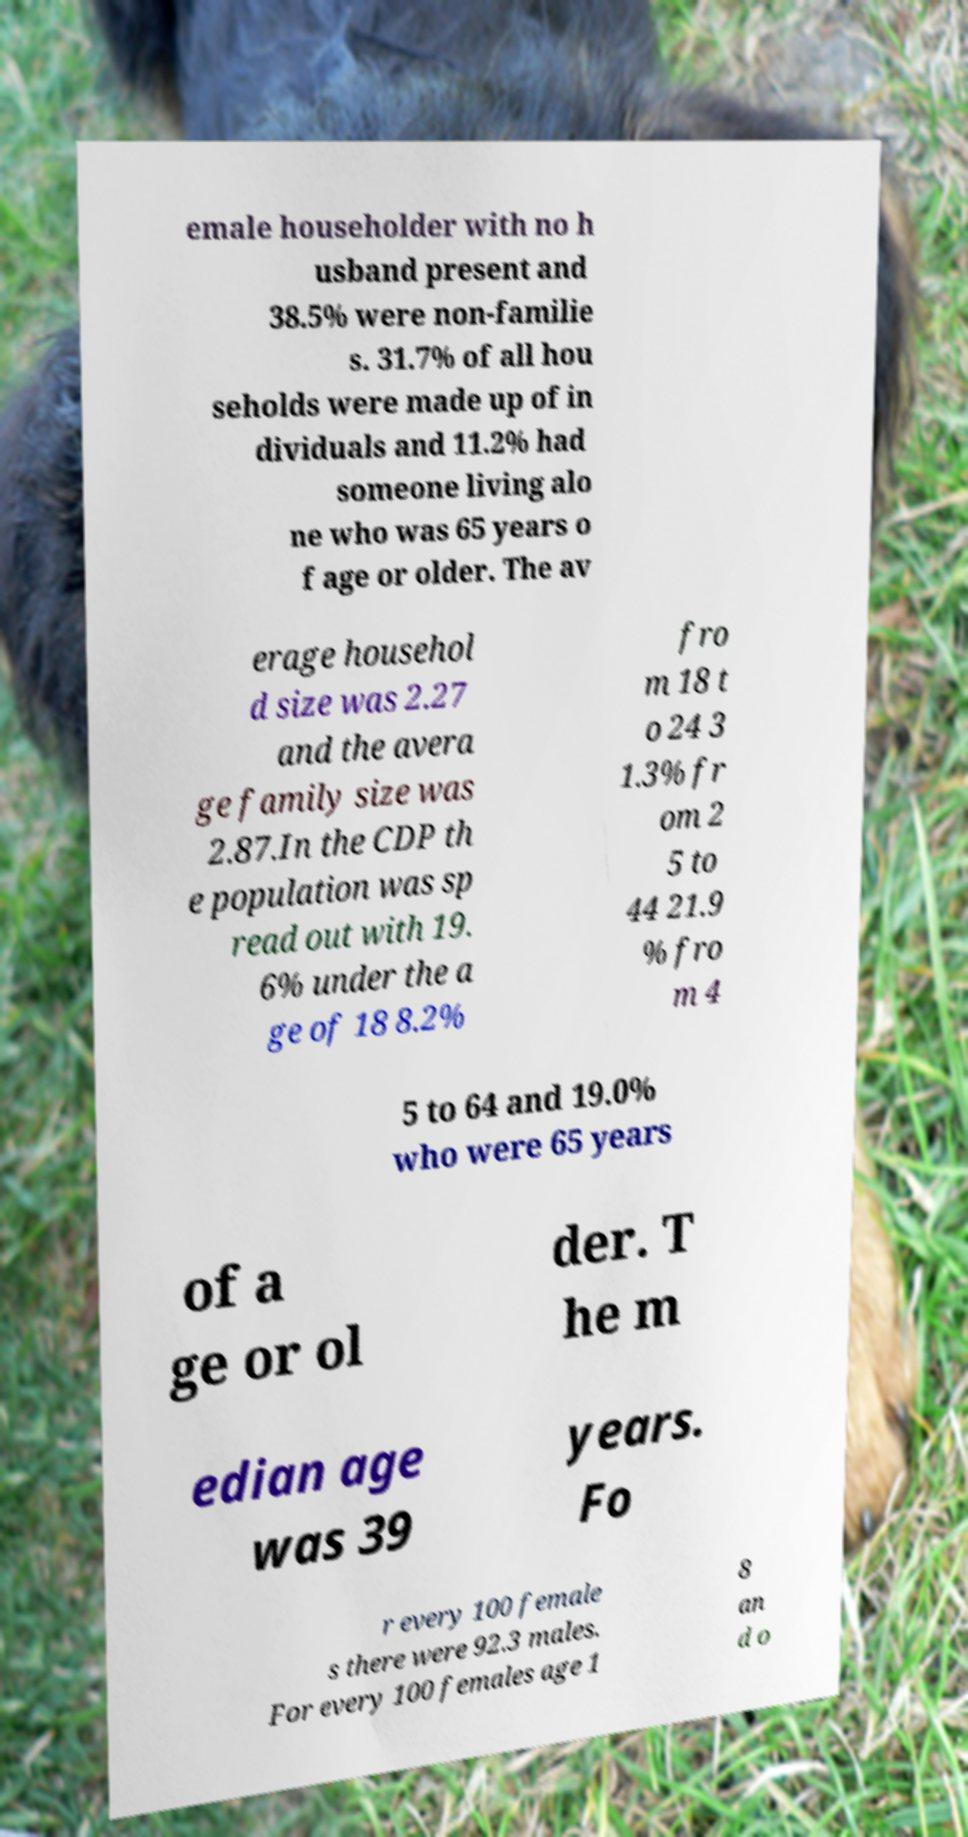Please identify and transcribe the text found in this image. emale householder with no h usband present and 38.5% were non-familie s. 31.7% of all hou seholds were made up of in dividuals and 11.2% had someone living alo ne who was 65 years o f age or older. The av erage househol d size was 2.27 and the avera ge family size was 2.87.In the CDP th e population was sp read out with 19. 6% under the a ge of 18 8.2% fro m 18 t o 24 3 1.3% fr om 2 5 to 44 21.9 % fro m 4 5 to 64 and 19.0% who were 65 years of a ge or ol der. T he m edian age was 39 years. Fo r every 100 female s there were 92.3 males. For every 100 females age 1 8 an d o 